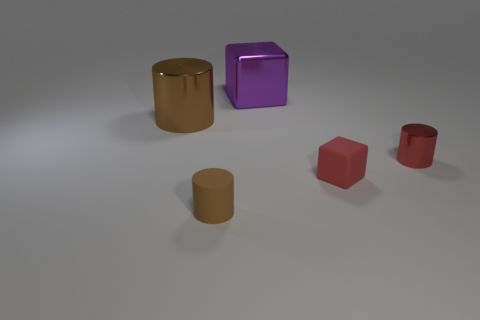There is another small thing that is the same color as the small metal object; what is its material?
Provide a short and direct response. Rubber. The shiny thing that is left of the small cylinder on the left side of the large metallic cube is what color?
Provide a short and direct response. Brown. How many matte things are either gray blocks or tiny red objects?
Provide a succinct answer. 1. Is the material of the red cube the same as the tiny brown object?
Your answer should be very brief. Yes. The thing that is behind the metal object that is to the left of the large purple object is made of what material?
Provide a succinct answer. Metal. What number of tiny objects are matte blocks or blue rubber spheres?
Offer a terse response. 1. What is the size of the brown metallic thing?
Offer a terse response. Large. Are there more tiny matte cylinders on the left side of the large brown shiny cylinder than red shiny objects?
Provide a succinct answer. No. Are there an equal number of red matte things that are to the left of the purple metal object and metallic objects right of the large cylinder?
Give a very brief answer. No. The cylinder that is both behind the small brown thing and on the left side of the purple shiny object is what color?
Keep it short and to the point. Brown. 